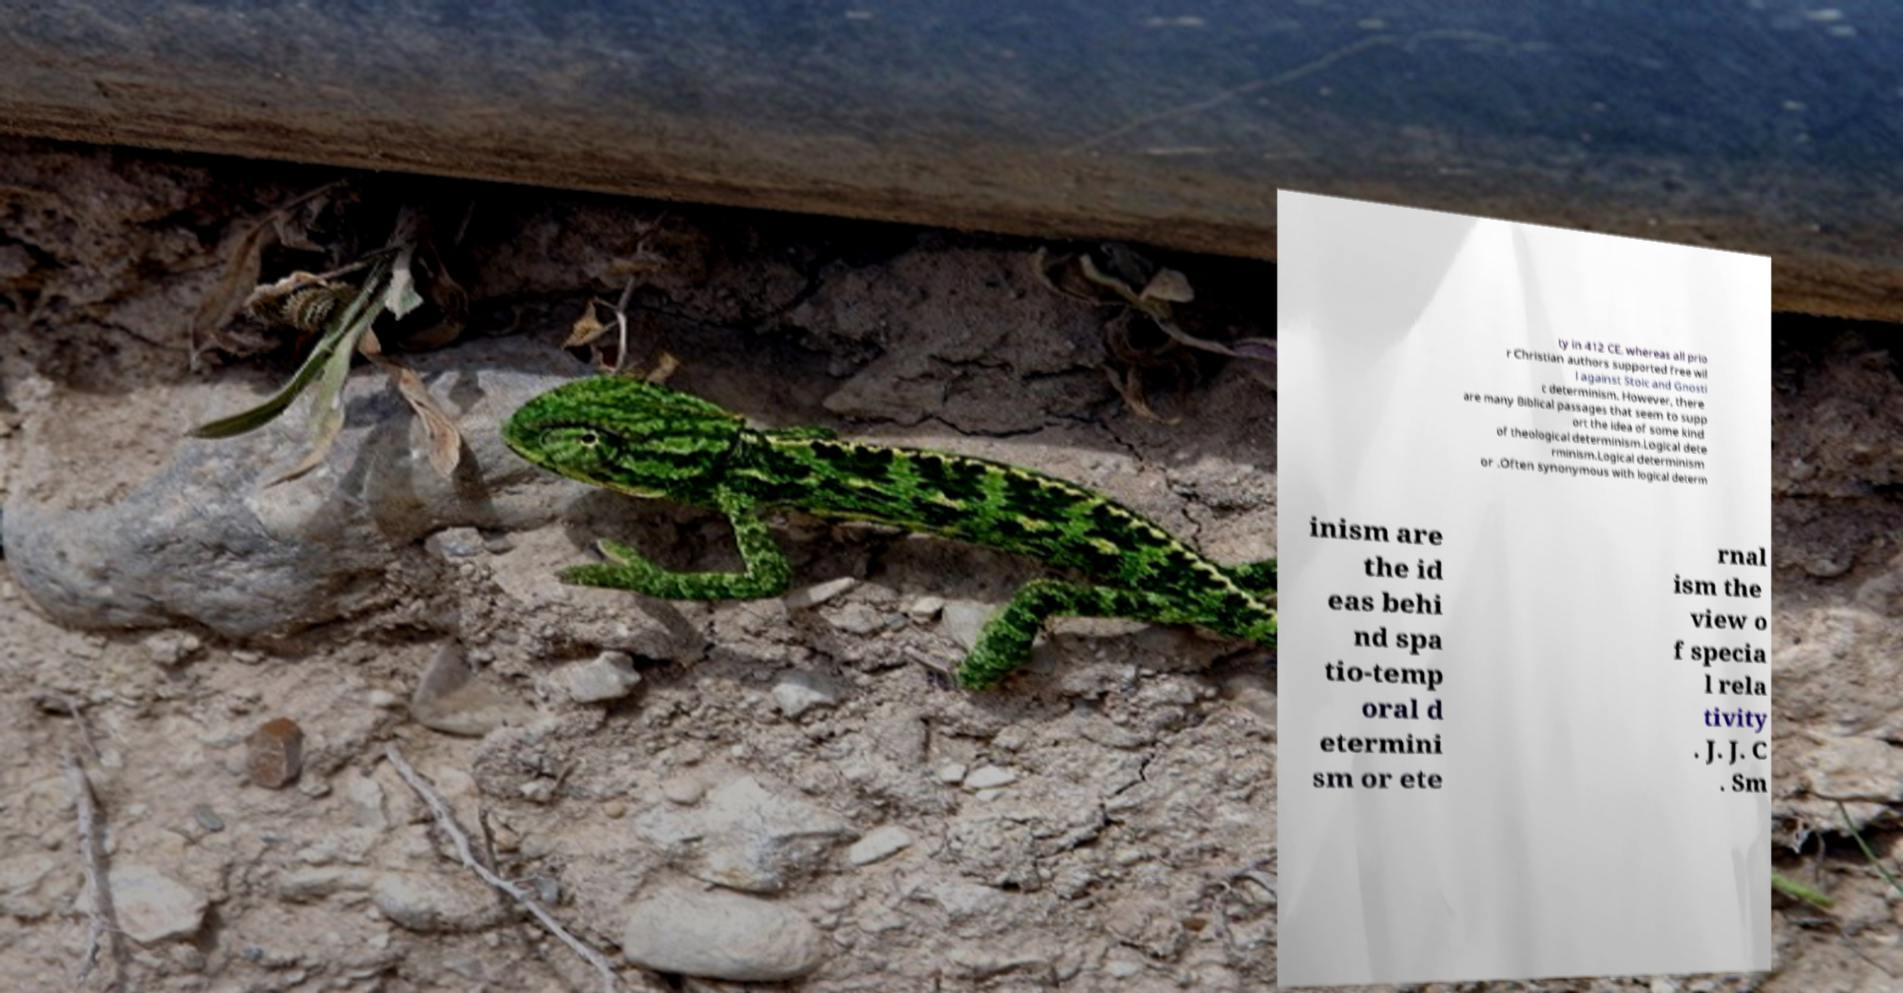Could you extract and type out the text from this image? ty in 412 CE, whereas all prio r Christian authors supported free wil l against Stoic and Gnosti c determinism. However, there are many Biblical passages that seem to supp ort the idea of some kind of theological determinism.Logical dete rminism.Logical determinism or .Often synonymous with logical determ inism are the id eas behi nd spa tio-temp oral d etermini sm or ete rnal ism the view o f specia l rela tivity . J. J. C . Sm 